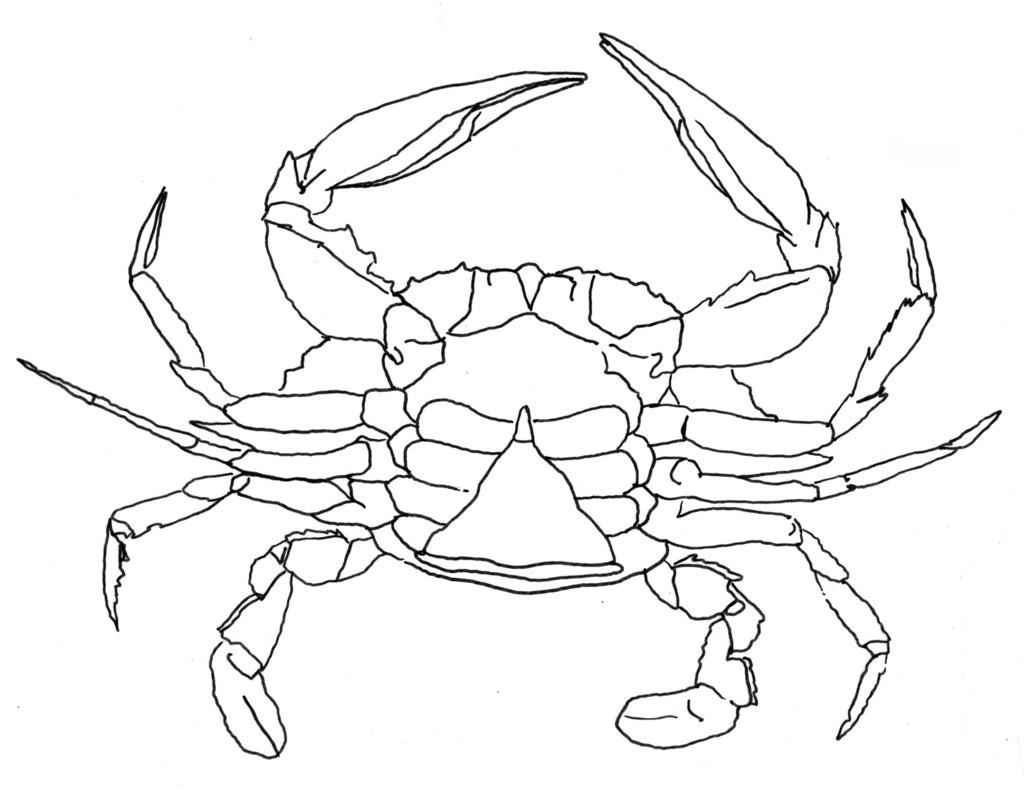What is depicted in the drawing in the image? There is a drawing of an animal in the image. What type of animal does the drawing resemble? The animal resembles a crab. What color is the background of the image? The background of the image is white. What type of breakfast is being served in the image? There is no breakfast depicted in the image; it features a drawing of an animal that resembles a crab on a white background. How many chickens are present in the image? There are no chickens present in the image; it features a drawing of an animal that resembles a crab on a white background. 